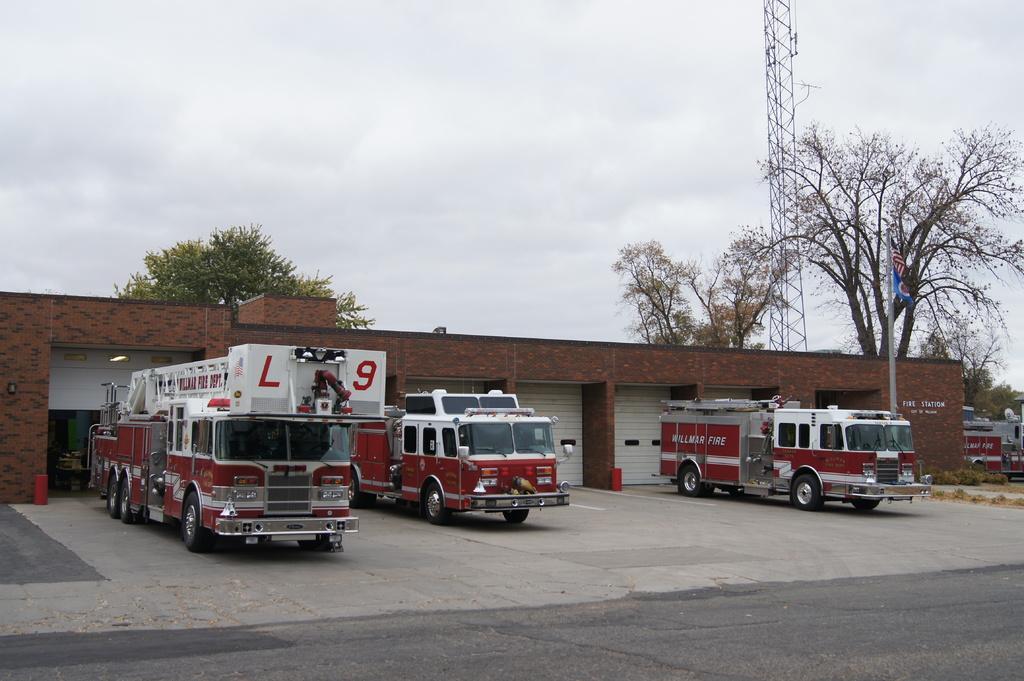Please provide a concise description of this image. In this picture we can see the road, shutters, vehicles on the ground, trees, pole, flag and in the background we can see the sky with clouds. 